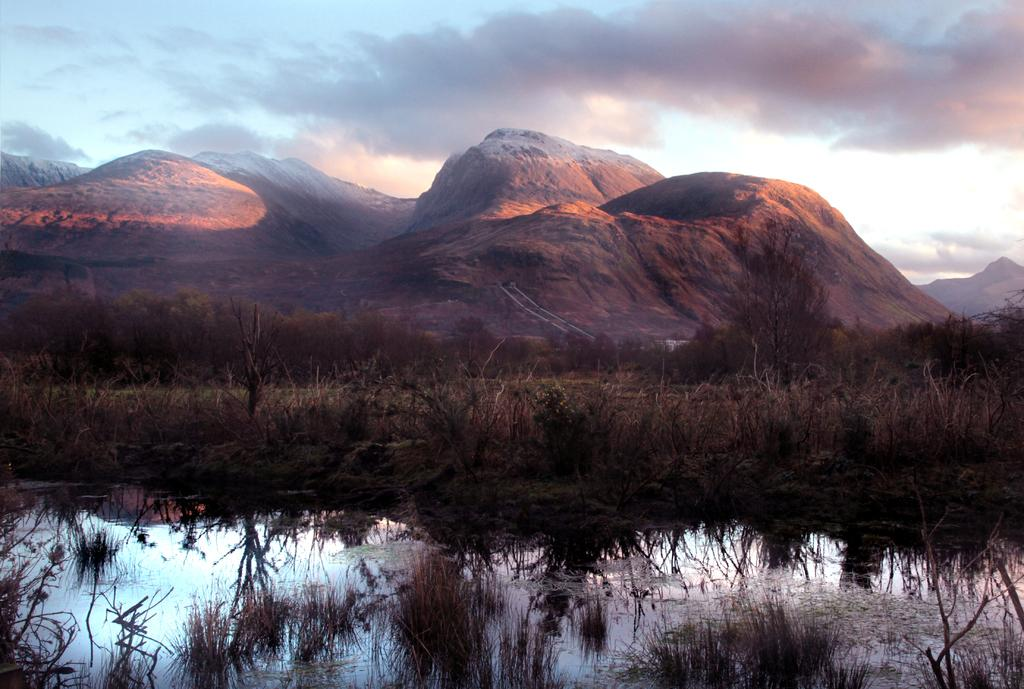What is the primary element present in the image? There is water in the image. What other natural elements can be seen in the image? There are plants, trees, and mountains visible in the image. What is the condition of the sky in the image? The sky is visible in the image and appears to be cloudy. Where is the lunchroom located in the image? There is no lunchroom present in the image. What decision must be made regarding the dolls in the image? There are no dolls present in the image, so no decision needs to be made. 